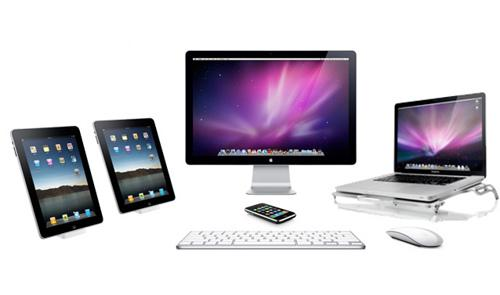What is in the middle? Please explain your reasoning. laptop. The middle is a laptop. 